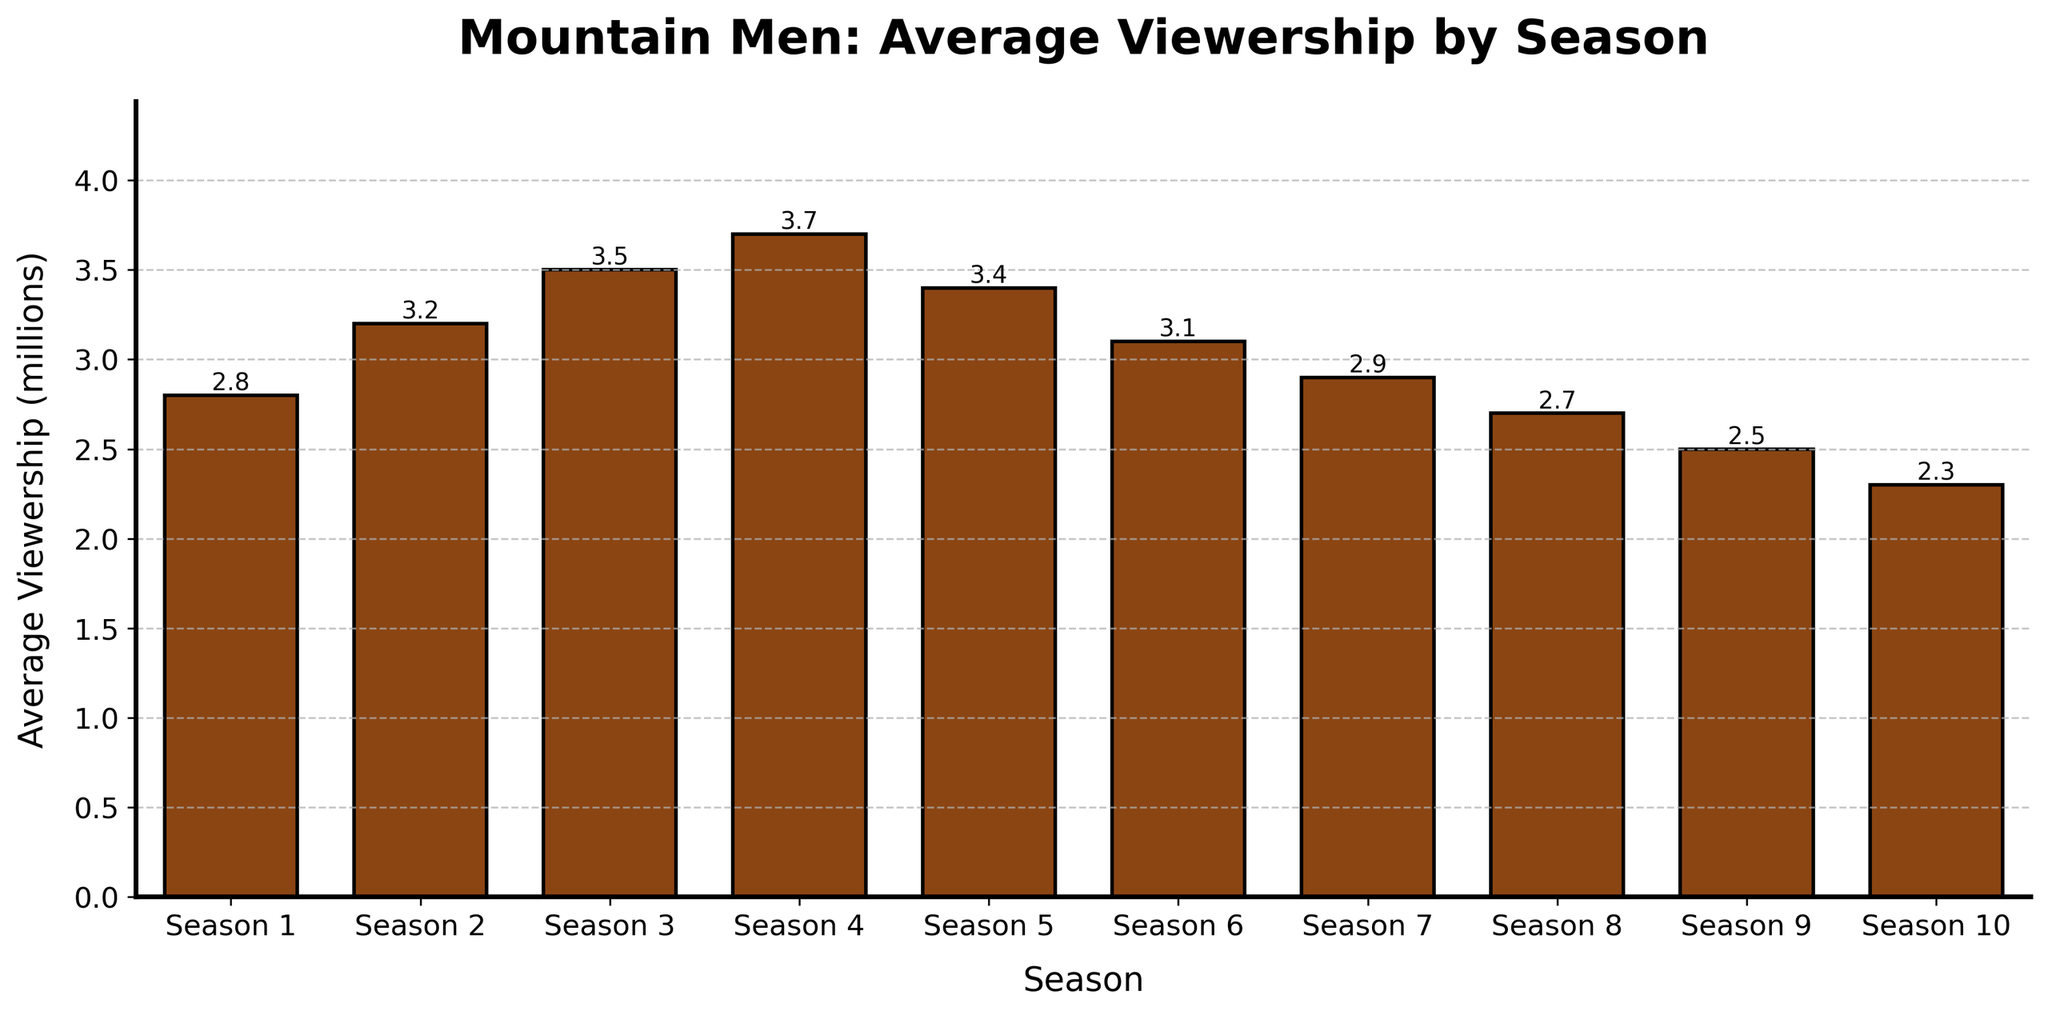Which season has the highest average viewership? By visually inspecting the bar chart, we observe that Season 4 has the tallest bar, indicating the highest average viewership.
Answer: Season 4 How much did the average viewership decrease from Season 4 to Season 10? From the chart, Season 4 had 3.7 million viewers, and Season 10 had 2.3 million viewers. Subtracting the two gives 3.7 - 2.3 = 1.4 million.
Answer: 1.4 million Which seasons have an average viewership that is above 3 million? From the bar chart, Seasons 2, 3, 4, and 5 all have bars that go above the 3 million mark.
Answer: Seasons 2, 3, 4, and 5 What is the average viewership of the first three seasons combined? The average viewerships for Seasons 1, 2, and 3 are 2.8, 3.2, and 3.5 million, respectively. The total is 2.8 + 3.2 + 3.5 = 9.5 million. The average is 9.5 / 3 ≈ 3.17 million.
Answer: 3.17 million Did the average viewership increase or decrease from Season 8 to Season 9, and by what amount? The average viewership for Season 8 is 2.7 million, and for Season 9, it is 2.5 million. The decrease is 2.7 - 2.5 = 0.2 million.
Answer: Decrease by 0.2 million What is the trend in viewership from Season 5 to Season 10? By examining the heights of the bars from Season 5 to Season 10, we observe a general downward trend in viewership: 3.4 to 3.1 to 2.9 to 2.7 to 2.5 to 2.3 million.
Answer: Downward trend Which seasons have lower average viewership than Season 1? From the chart, Seasons 8, 9, and 10 have lower average viewerships than Season 1's 2.8 million viewers.
Answer: Seasons 8, 9, and 10 What's the average viewership over all ten seasons? Summing the viewership numbers (2.8 + 3.2 + 3.5 + 3.7 + 3.4 + 3.1 + 2.9 + 2.7 + 2.5 + 2.3 = 30.1) and dividing by 10 seasons gives an average of 30.1 / 10 = 3.01 million.
Answer: 3.01 million 